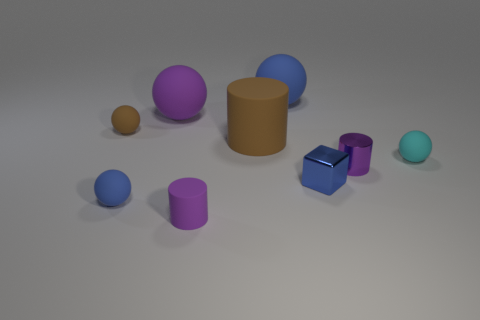How many objects are there in total in the image? Upon reviewing the image, there are a total of eight objects present.  Which object is the largest? The largest object in the image appears to be the tan-colored cylindrical shape. 